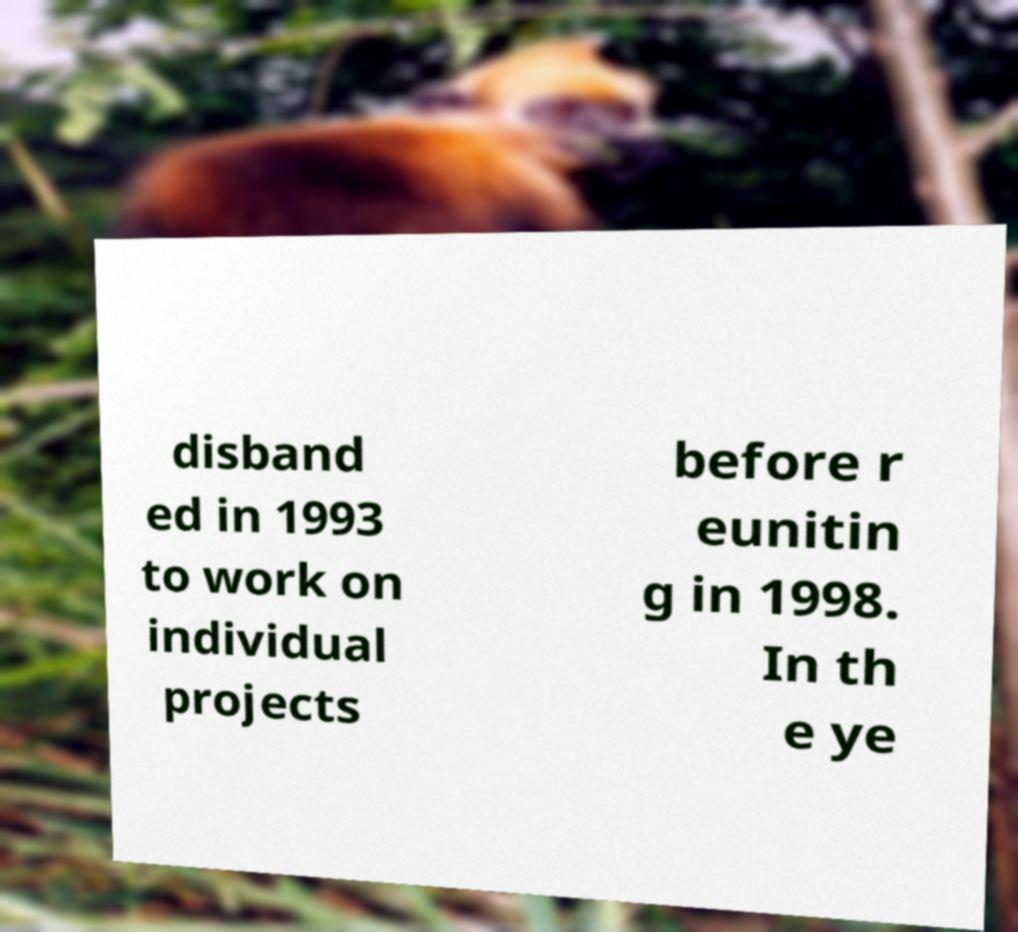For documentation purposes, I need the text within this image transcribed. Could you provide that? disband ed in 1993 to work on individual projects before r eunitin g in 1998. In th e ye 